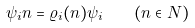Convert formula to latex. <formula><loc_0><loc_0><loc_500><loc_500>\psi _ { i } n = \varrho _ { i } ( n ) \psi _ { i } \quad ( n \in N )</formula> 